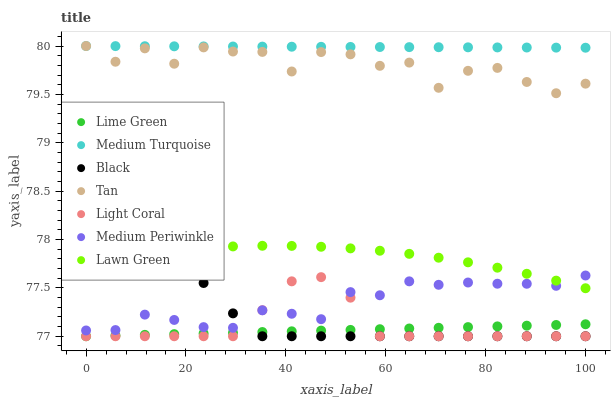Does Lime Green have the minimum area under the curve?
Answer yes or no. Yes. Does Medium Turquoise have the maximum area under the curve?
Answer yes or no. Yes. Does Medium Periwinkle have the minimum area under the curve?
Answer yes or no. No. Does Medium Periwinkle have the maximum area under the curve?
Answer yes or no. No. Is Medium Turquoise the smoothest?
Answer yes or no. Yes. Is Tan the roughest?
Answer yes or no. Yes. Is Medium Periwinkle the smoothest?
Answer yes or no. No. Is Medium Periwinkle the roughest?
Answer yes or no. No. Does Light Coral have the lowest value?
Answer yes or no. Yes. Does Medium Periwinkle have the lowest value?
Answer yes or no. No. Does Tan have the highest value?
Answer yes or no. Yes. Does Medium Periwinkle have the highest value?
Answer yes or no. No. Is Light Coral less than Medium Turquoise?
Answer yes or no. Yes. Is Medium Periwinkle greater than Lime Green?
Answer yes or no. Yes. Does Black intersect Lawn Green?
Answer yes or no. Yes. Is Black less than Lawn Green?
Answer yes or no. No. Is Black greater than Lawn Green?
Answer yes or no. No. Does Light Coral intersect Medium Turquoise?
Answer yes or no. No. 